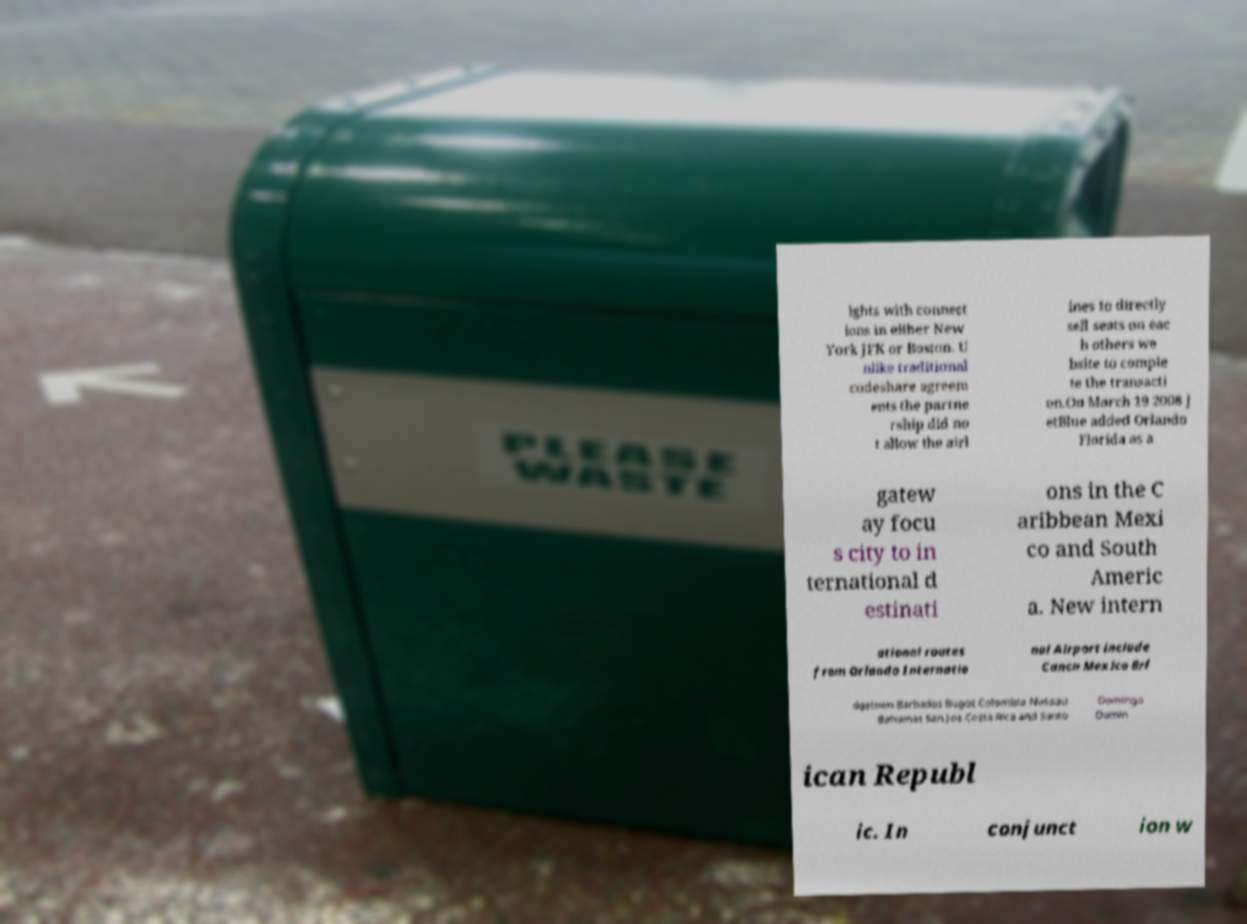Can you accurately transcribe the text from the provided image for me? ights with connect ions in either New York JFK or Boston. U nlike traditional codeshare agreem ents the partne rship did no t allow the airl ines to directly sell seats on eac h others we bsite to comple te the transacti on.On March 19 2008 J etBlue added Orlando Florida as a gatew ay focu s city to in ternational d estinati ons in the C aribbean Mexi co and South Americ a. New intern ational routes from Orlando Internatio nal Airport include Cancn Mexico Bri dgetown Barbados Bogot Colombia Nassau Bahamas San Jos Costa Rica and Santo Domingo Domin ican Republ ic. In conjunct ion w 